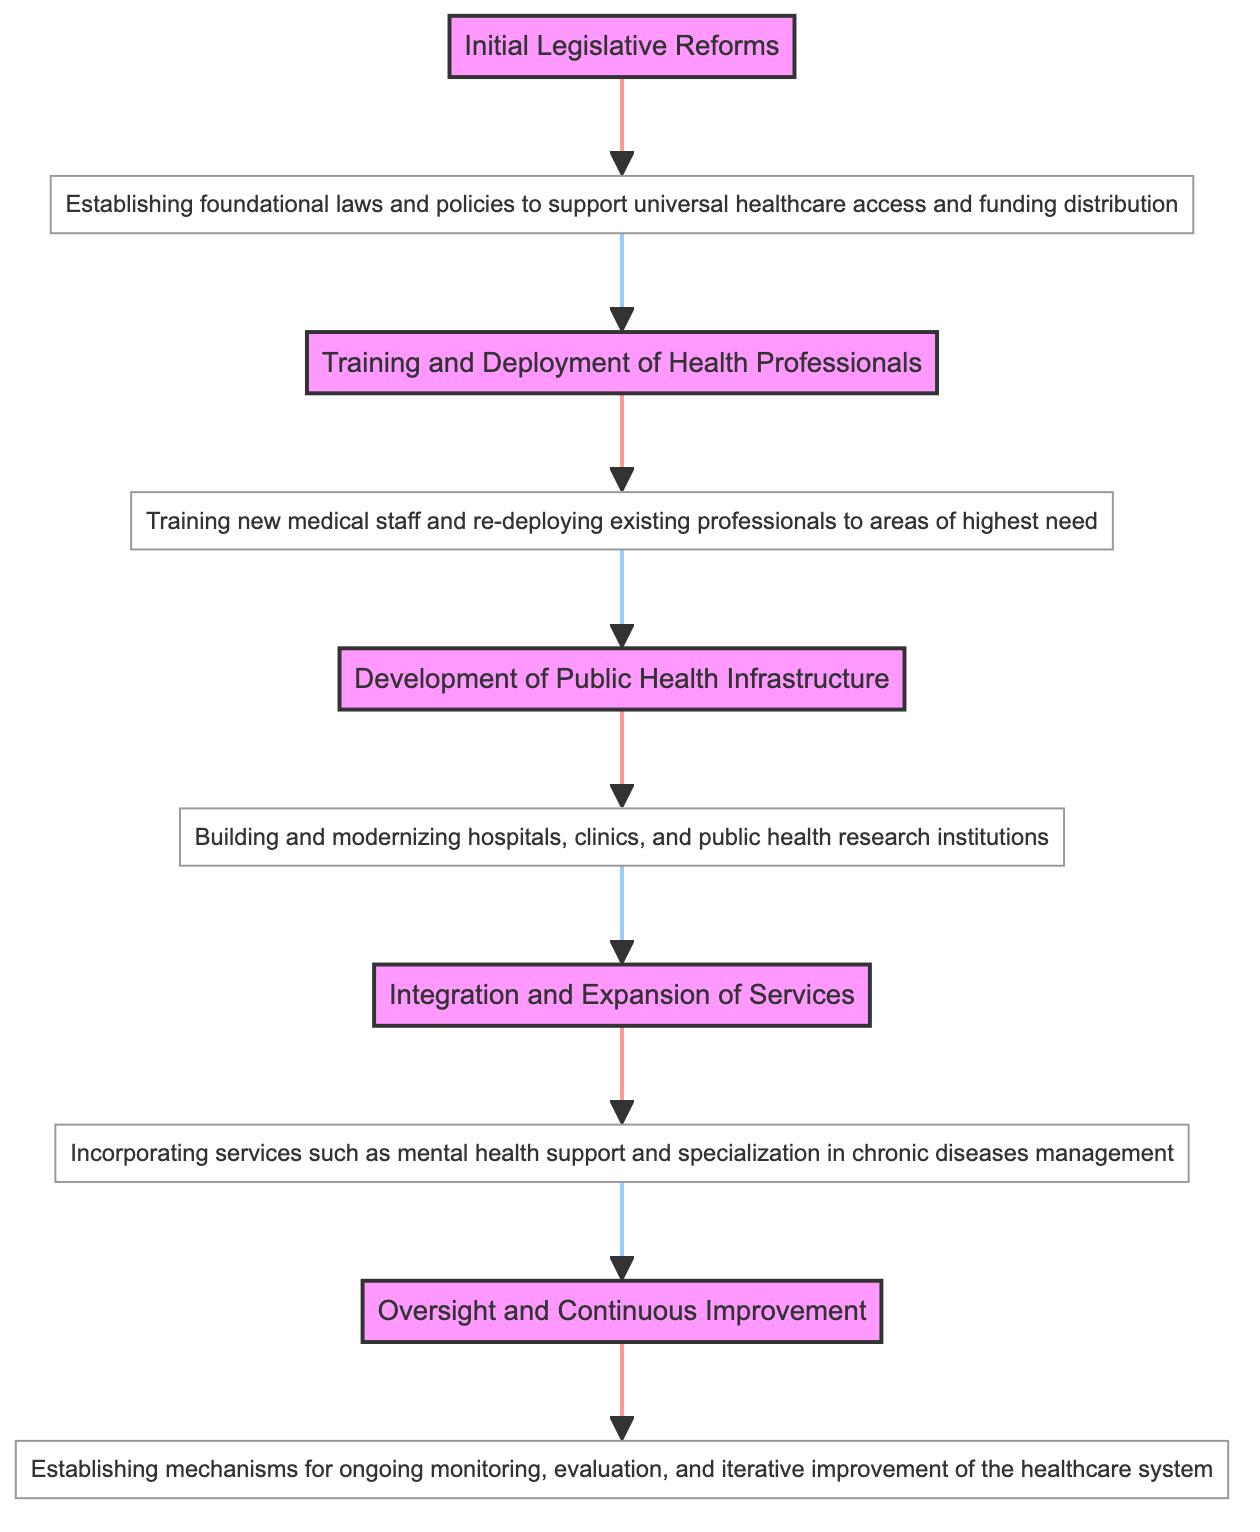What is the final phase in the implementation of healthcare reforms? The diagram shows five phases, with the last one being "Oversight and Continuous Improvement."
Answer: Oversight and Continuous Improvement How many phases are represented in the diagram? The diagram visually distinguishes five phases in total for the implementation of healthcare reforms.
Answer: Five What phase comes after "Development of Public Health Infrastructure"? Following the phase of "Development of Public Health Infrastructure," the next phase is "Integration and Expansion of Services."
Answer: Integration and Expansion of Services What is the description for "Training and Deployment of Health Professionals"? The diagram specifies that "Training and Deployment of Health Professionals" involves "Training new medical staff and re-deploying existing professionals to areas of highest need."
Answer: Training new medical staff and re-deploying existing professionals to areas of highest need How many descriptive nodes are present in the diagram? The diagram has a total of five descriptive nodes corresponding to each of the five phases of healthcare reforms.
Answer: Five What is the relationship between "Initial Legislative Reforms" and "Training and Deployment of Health Professionals"? The diagram connects "Initial Legislative Reforms" directly to "Training and Deployment of Health Professionals," indicating that the latter follows from the former.
Answer: Direct connection Which phase is associated with establishing laws for universal healthcare access? The phase associated with establishing foundational laws for universal healthcare access is "Initial Legislative Reforms."
Answer: Initial Legislative Reforms What is the purpose of the phase "Oversight and Continuous Improvement"? The purpose of this phase is to establish mechanisms for ongoing monitoring, evaluation, and iterative improvement of the healthcare system.
Answer: Ongoing monitoring, evaluation, and iterative improvement What is the first phase in the healthcare reform implementation? The first phase depicted in the diagram is "Initial Legislative Reforms."
Answer: Initial Legislative Reforms 